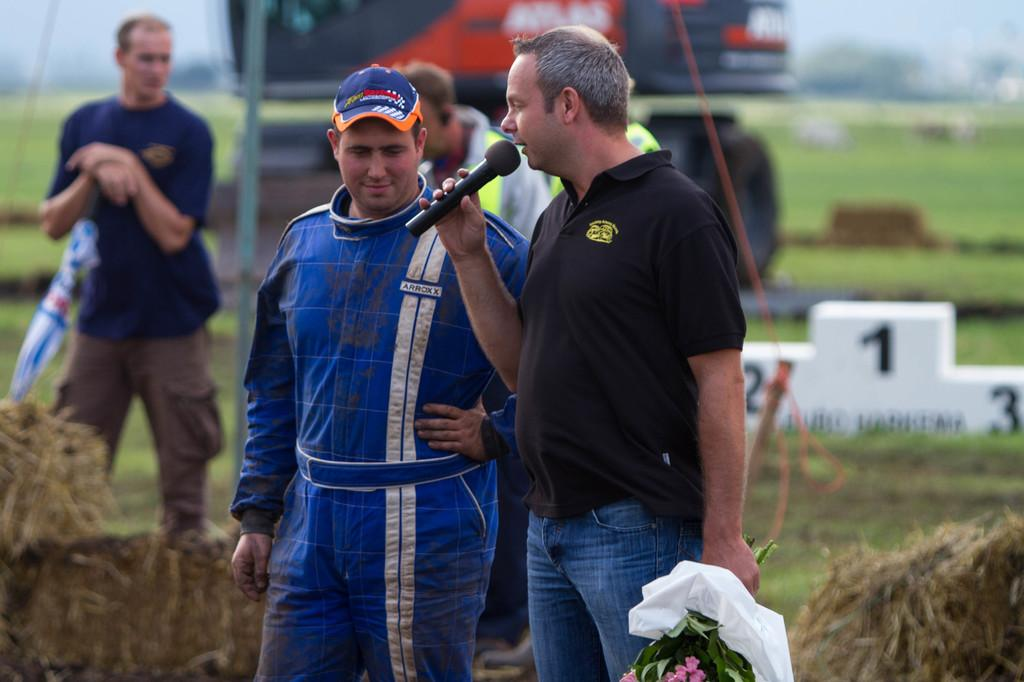What is happening in the image? There are people standing on the land in the image. Can you describe any specific actions or objects being held by the people? One of the people is holding a mic in his hand. What can be observed about the background of the image? The background of the image is blurred. What type of quartz can be seen in the nest in the image? There is no quartz or nest present in the image. 